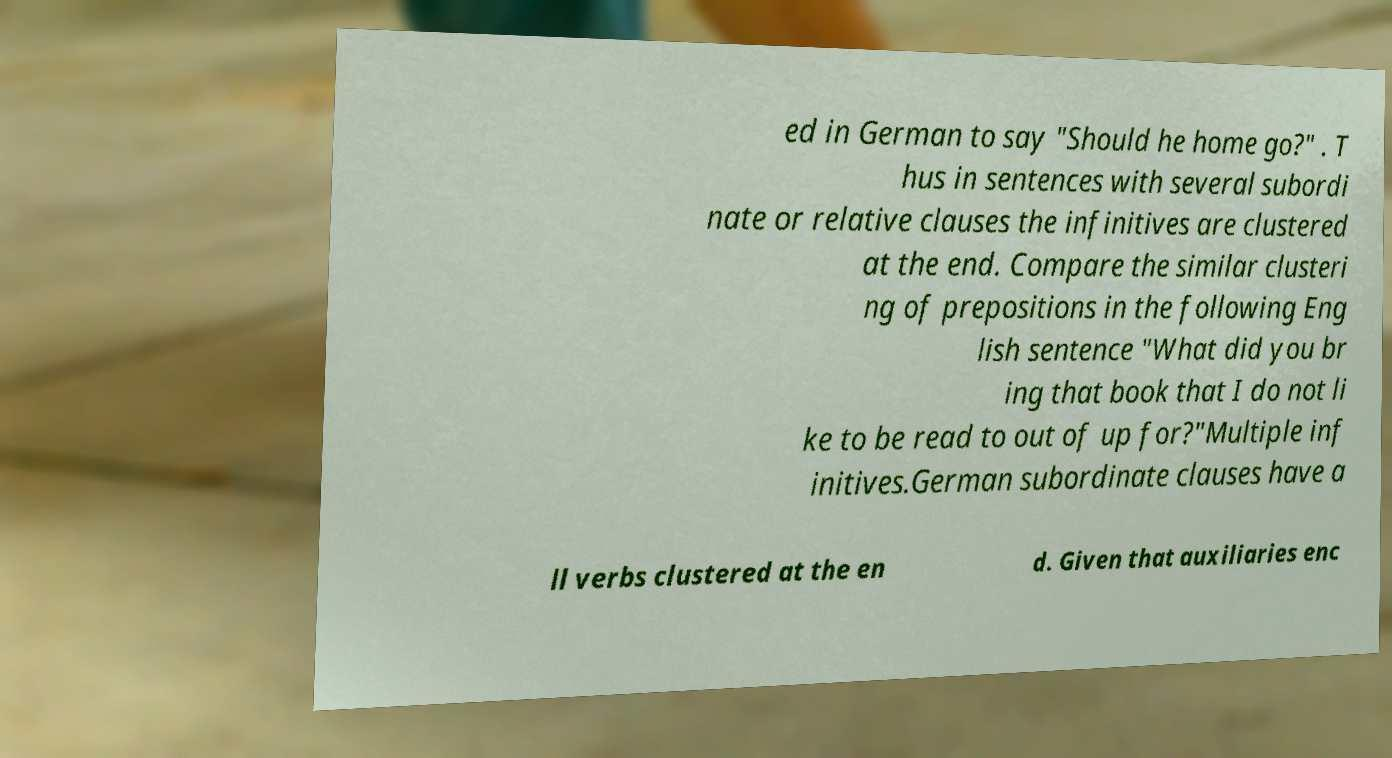Could you extract and type out the text from this image? ed in German to say "Should he home go?" . T hus in sentences with several subordi nate or relative clauses the infinitives are clustered at the end. Compare the similar clusteri ng of prepositions in the following Eng lish sentence "What did you br ing that book that I do not li ke to be read to out of up for?"Multiple inf initives.German subordinate clauses have a ll verbs clustered at the en d. Given that auxiliaries enc 